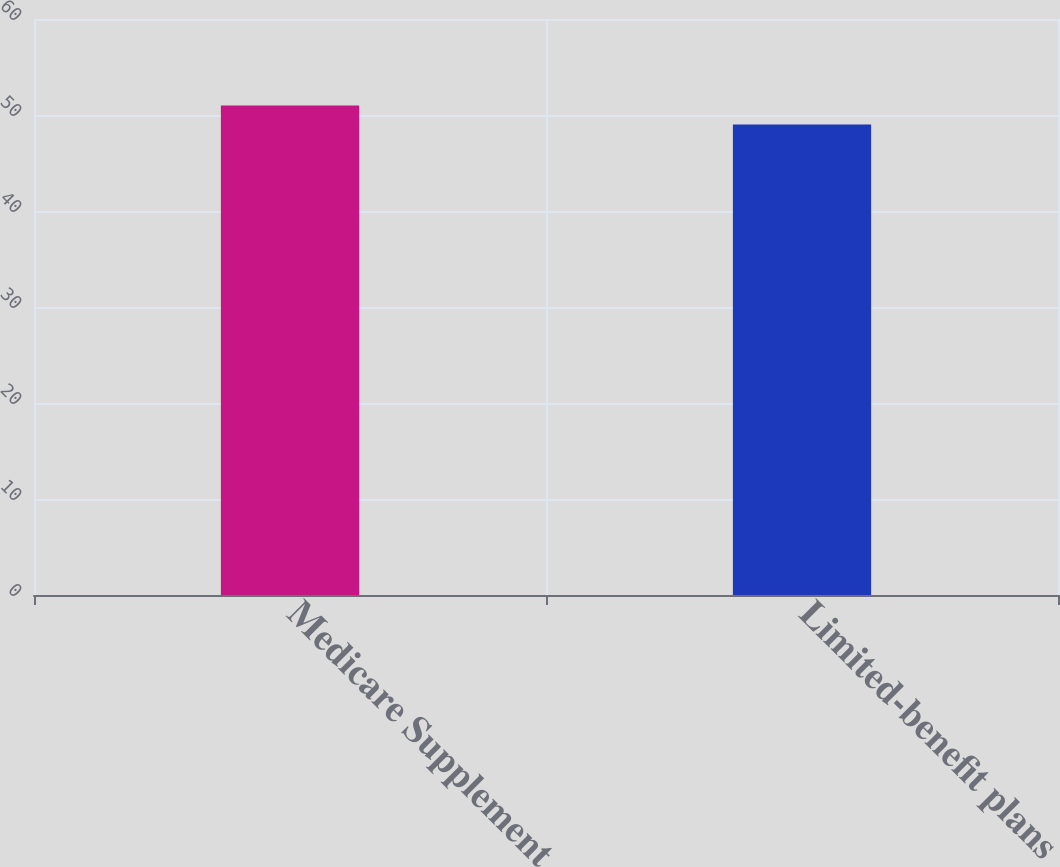<chart> <loc_0><loc_0><loc_500><loc_500><bar_chart><fcel>Medicare Supplement<fcel>Limited-benefit plans<nl><fcel>51<fcel>49<nl></chart> 